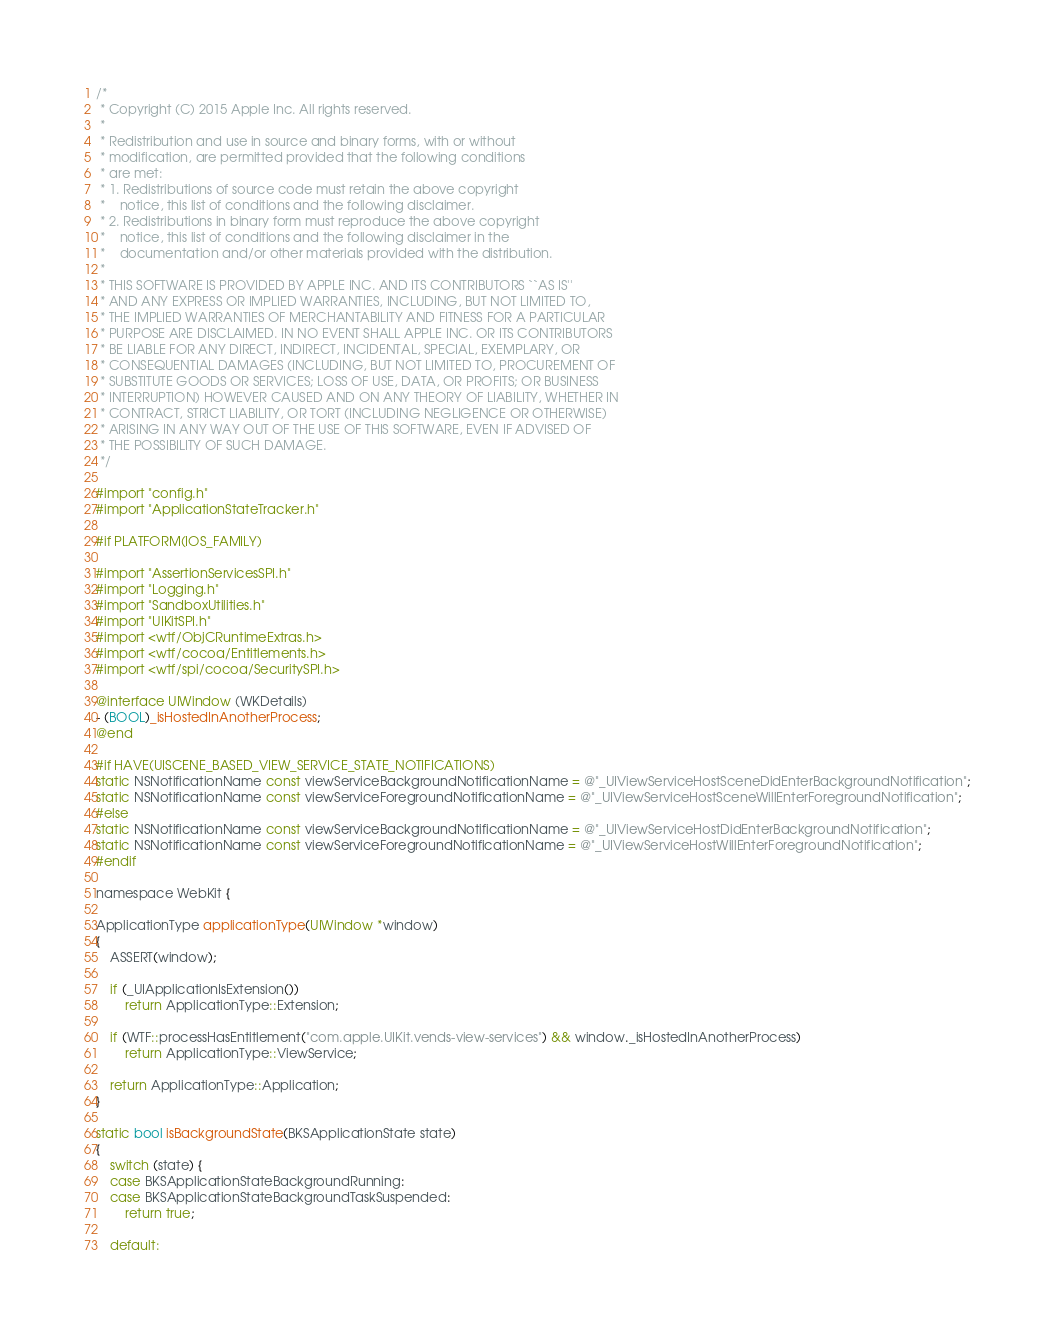<code> <loc_0><loc_0><loc_500><loc_500><_ObjectiveC_>/*
 * Copyright (C) 2015 Apple Inc. All rights reserved.
 *
 * Redistribution and use in source and binary forms, with or without
 * modification, are permitted provided that the following conditions
 * are met:
 * 1. Redistributions of source code must retain the above copyright
 *    notice, this list of conditions and the following disclaimer.
 * 2. Redistributions in binary form must reproduce the above copyright
 *    notice, this list of conditions and the following disclaimer in the
 *    documentation and/or other materials provided with the distribution.
 *
 * THIS SOFTWARE IS PROVIDED BY APPLE INC. AND ITS CONTRIBUTORS ``AS IS''
 * AND ANY EXPRESS OR IMPLIED WARRANTIES, INCLUDING, BUT NOT LIMITED TO,
 * THE IMPLIED WARRANTIES OF MERCHANTABILITY AND FITNESS FOR A PARTICULAR
 * PURPOSE ARE DISCLAIMED. IN NO EVENT SHALL APPLE INC. OR ITS CONTRIBUTORS
 * BE LIABLE FOR ANY DIRECT, INDIRECT, INCIDENTAL, SPECIAL, EXEMPLARY, OR
 * CONSEQUENTIAL DAMAGES (INCLUDING, BUT NOT LIMITED TO, PROCUREMENT OF
 * SUBSTITUTE GOODS OR SERVICES; LOSS OF USE, DATA, OR PROFITS; OR BUSINESS
 * INTERRUPTION) HOWEVER CAUSED AND ON ANY THEORY OF LIABILITY, WHETHER IN
 * CONTRACT, STRICT LIABILITY, OR TORT (INCLUDING NEGLIGENCE OR OTHERWISE)
 * ARISING IN ANY WAY OUT OF THE USE OF THIS SOFTWARE, EVEN IF ADVISED OF
 * THE POSSIBILITY OF SUCH DAMAGE.
 */

#import "config.h"
#import "ApplicationStateTracker.h"

#if PLATFORM(IOS_FAMILY)

#import "AssertionServicesSPI.h"
#import "Logging.h"
#import "SandboxUtilities.h"
#import "UIKitSPI.h"
#import <wtf/ObjCRuntimeExtras.h>
#import <wtf/cocoa/Entitlements.h>
#import <wtf/spi/cocoa/SecuritySPI.h>

@interface UIWindow (WKDetails)
- (BOOL)_isHostedInAnotherProcess;
@end

#if HAVE(UISCENE_BASED_VIEW_SERVICE_STATE_NOTIFICATIONS)
static NSNotificationName const viewServiceBackgroundNotificationName = @"_UIViewServiceHostSceneDidEnterBackgroundNotification";
static NSNotificationName const viewServiceForegroundNotificationName = @"_UIViewServiceHostSceneWillEnterForegroundNotification";
#else
static NSNotificationName const viewServiceBackgroundNotificationName = @"_UIViewServiceHostDidEnterBackgroundNotification";
static NSNotificationName const viewServiceForegroundNotificationName = @"_UIViewServiceHostWillEnterForegroundNotification";
#endif

namespace WebKit {

ApplicationType applicationType(UIWindow *window)
{
    ASSERT(window);

    if (_UIApplicationIsExtension())
        return ApplicationType::Extension;

    if (WTF::processHasEntitlement("com.apple.UIKit.vends-view-services") && window._isHostedInAnotherProcess)
        return ApplicationType::ViewService;

    return ApplicationType::Application;
}

static bool isBackgroundState(BKSApplicationState state)
{
    switch (state) {
    case BKSApplicationStateBackgroundRunning:
    case BKSApplicationStateBackgroundTaskSuspended:
        return true;

    default:</code> 